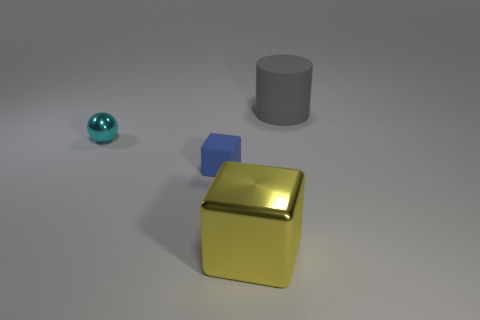Can you describe the texture and color of the largest object? The largest object in the image is a shiny yellow block with a metallic texture, reflecting light to give it a glossy appearance. 